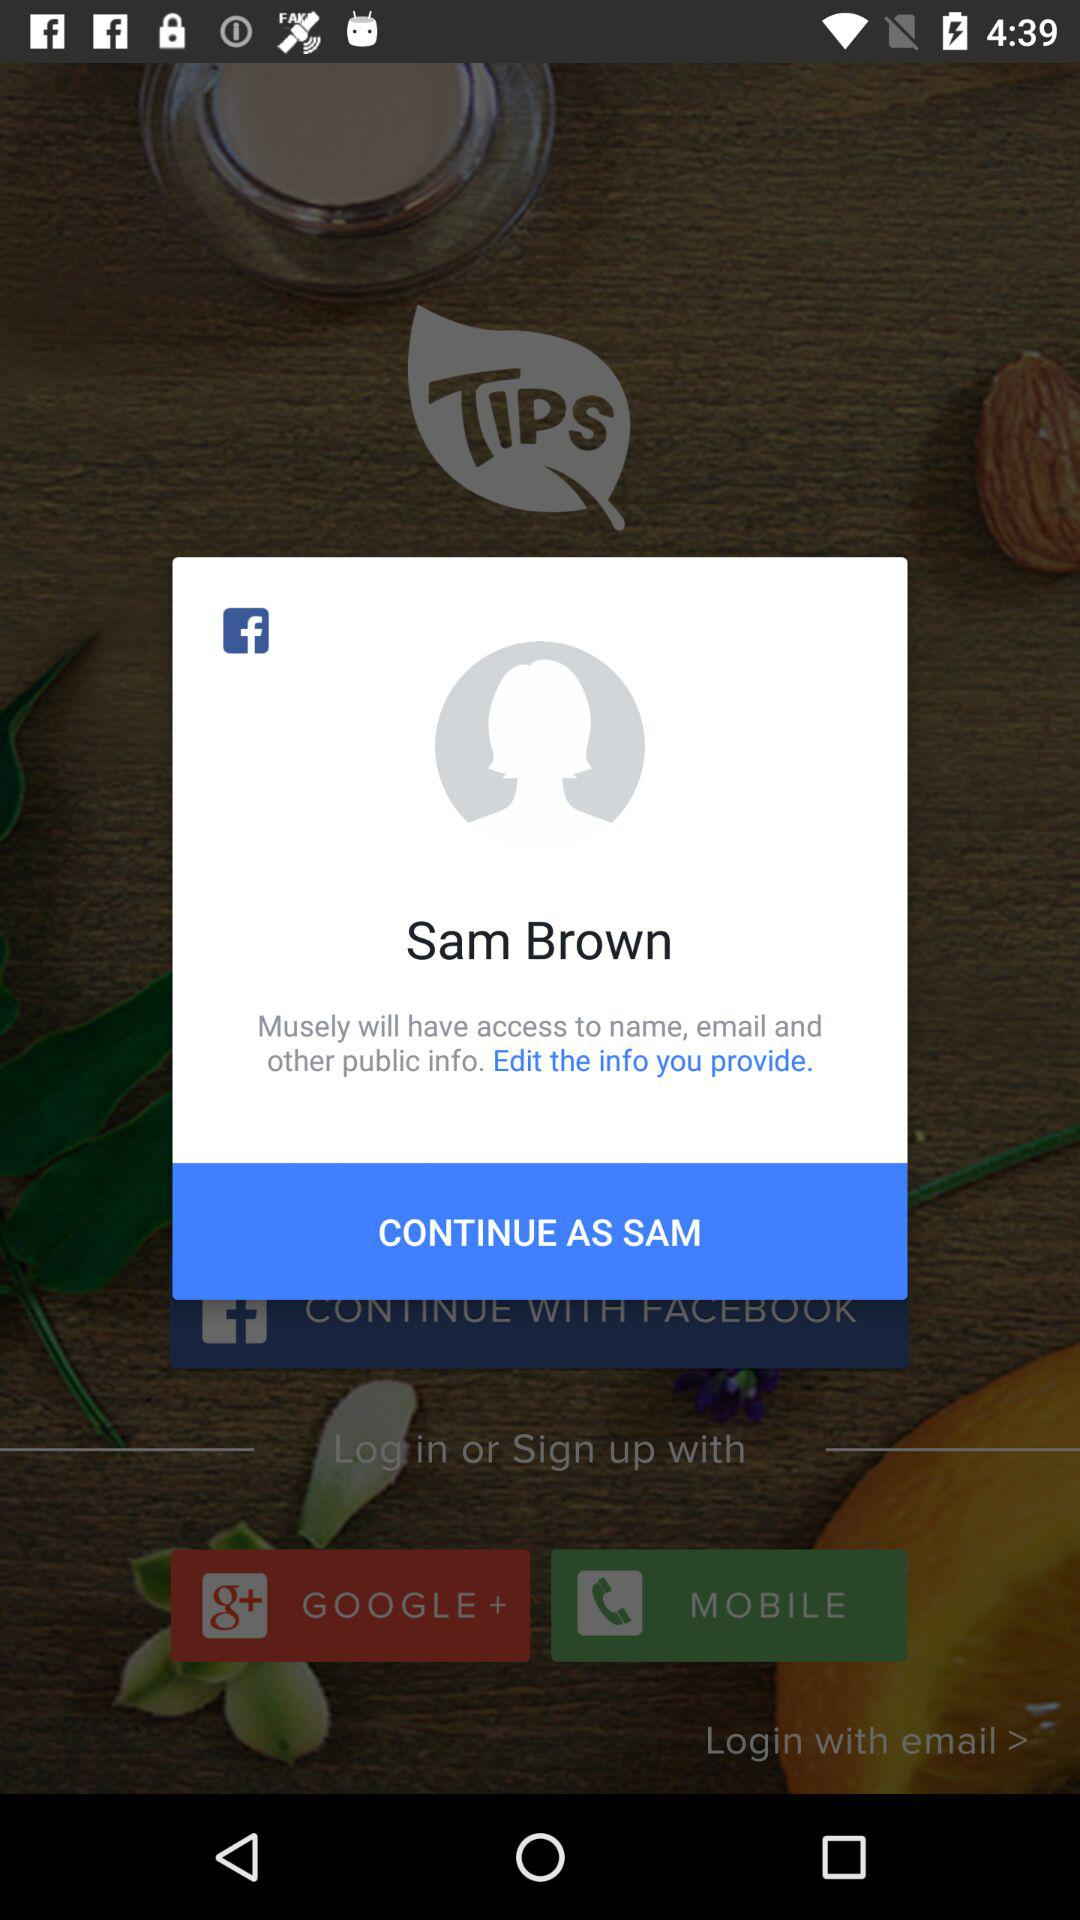What application is asking for permission? The application asking for permission is "Musely". 